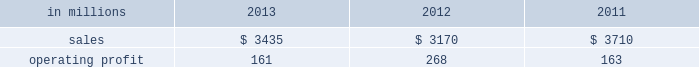Sales volumes in 2013 increased from 2012 , primarily for fluff pulp , reflecting improved market demand and a change in our product mix with a full year of fluff pulp production at our franklin , virginia mill .
Average sales price realizations were lower for fluff pulp while prices for market pulp increased .
Input costs for wood , fuels and chemicals were higher .
Mill operating costs were significantly lower largely due to the absence of costs associated with the start-up of the franklin mill in 2012 .
Planned maintenance downtime costs were higher .
In the first quarter of 2014 , sales volumes are expected to be slightly lower compared with the fourth quarter of 2013 .
Average sales price realizations are expected to improve , reflecting the further realization of previously announced sales price increases for softwood pulp and fluff pulp .
Input costs should be flat .
Planned maintenance downtime costs should be about $ 11 million higher than in the fourth quarter of 2013 .
Operating profits will also be negatively impacted by the severe winter weather in the first quarter of 2014 .
Consumer packaging demand and pricing for consumer packaging products correlate closely with consumer spending and general economic activity .
In addition to prices and volumes , major factors affecting the profitability of consumer packaging are raw material and energy costs , freight costs , manufacturing efficiency and product mix .
Consumer packaging net sales in 2013 increased 8% ( 8 % ) from 2012 , but decreased 7% ( 7 % ) from 2011 .
Operating profits decreased 40% ( 40 % ) from 2012 and 1% ( 1 % ) from 2011 .
Net sales and operating profits include the shorewood business in 2011 .
Excluding costs associated with the permanent shutdown of a paper machine at our augusta , georgia mill and costs associated with the sale of the shorewood business , 2013 operating profits were 22% ( 22 % ) lower than in 2012 , and 43% ( 43 % ) lower than in 2011 .
Benefits from higher sales volumes ( $ 45 million ) were offset by lower average sales price realizations and an unfavorable mix ( $ 50 million ) , higher operating costs including incremental costs resulting from the shutdown of a paper machine at our augusta , georgia mill ( $ 46 million ) and higher input costs ( $ 6 million ) .
In addition , operating profits in 2013 included restructuring costs of $ 45 million related to the permanent shutdown of a paper machine at our augusta , georgia mill and $ 2 million of costs associated with the sale of the shorewood business .
Operating profits in 2012 included a gain of $ 3 million related to the sale of the shorewood business , while operating profits in 2011 included a $ 129 million fixed asset impairment charge for the north american shorewood business and $ 72 million for other charges associated with the sale of the shorewood business .
Consumer packaging .
North american consumer packaging net sales were $ 2.0 billion in 2013 compared with $ 2.0 billion in 2012 and $ 2.5 billion in 2011 .
Operating profits were $ 63 million ( $ 110 million excluding paper machine shutdown costs and costs related to the sale of the shorewood business ) in 2013 compared with $ 165 million ( $ 162 million excluding charges associated with the sale of the shorewood business ) in 2012 and $ 35 million ( $ 236 million excluding asset impairment charges and other costs associated with the sale of the shorewood business ) in 2011 .
Coated paperboard sales volumes in 2013 were higher than in 2012 reflecting stronger market demand .
Average sales price realizations were lower year-over- year despite the realization of price increases in the second half of 2013 .
Input costs for wood and energy increased , but were partially offset by lower costs for chemicals .
Planned maintenance downtime costs were slightly lower .
Market-related downtime was about 24000 tons in 2013 compared with about 113000 tons in 2012 .
The permanent shutdown of a paper machine at our augusta , georgia mill in the first quarter of 2013 reduced capacity by 140000 tons in 2013 compared with 2012 .
Foodservice sales volumes increased slightly in 2013 compared with 2012 despite softer market demand .
Average sales margins were higher reflecting lower input costs for board and resins and a more favorable product mix .
Operating costs and distribution costs were both higher .
The u.s.shorewood business was sold december 31 , 2011 and the non-u.s .
Business was sold in january looking ahead to the first quarter of 2014 , coated paperboard sales volumes are expected to be seasonally weaker than in the fourth quarter of 2013 .
Average sales price realizations are expected to be slightly higher , and margins should also benefit from a more favorable product mix .
Input costs are expected to be higher for energy , chemicals and wood .
Planned maintenance downtime costs should be $ 8 million lower with a planned maintenance outage scheduled at the augusta mill in the first quarter .
The severe winter weather in the first quarter of 2014 will negatively impact operating profits .
Foodservice sales volumes are expected to be seasonally lower .
Average sales margins are expected to improve due to the realization of sales price increases effective with our january contract openers and a more favorable product mix. .
What was the printing papers profit margin in 2011? 
Computations: (163 / 3710)
Answer: 0.04394. 